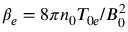Convert formula to latex. <formula><loc_0><loc_0><loc_500><loc_500>\beta _ { e } = 8 \pi n _ { 0 } T _ { 0 e } / B _ { 0 } ^ { 2 }</formula> 